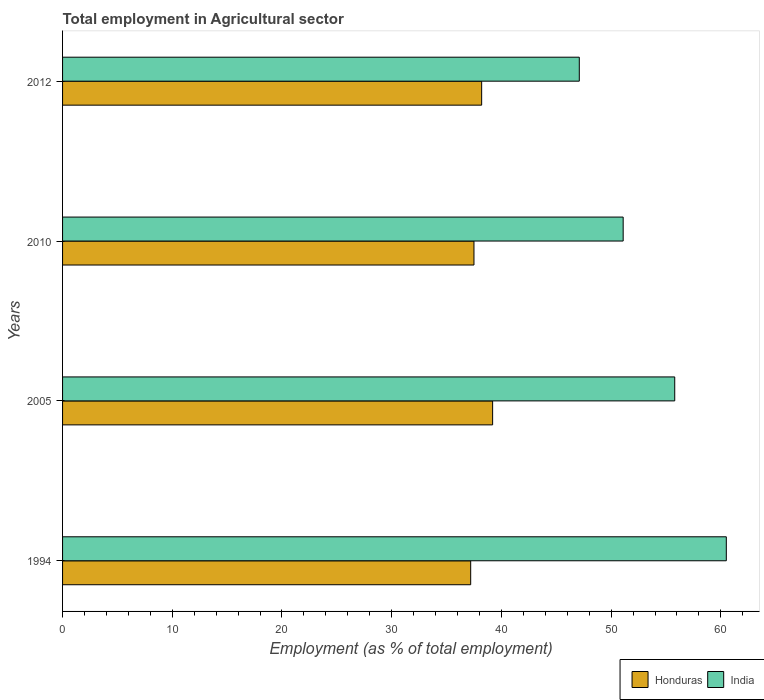How many different coloured bars are there?
Give a very brief answer. 2. How many groups of bars are there?
Provide a succinct answer. 4. Are the number of bars per tick equal to the number of legend labels?
Keep it short and to the point. Yes. What is the employment in agricultural sector in India in 2005?
Provide a succinct answer. 55.8. Across all years, what is the maximum employment in agricultural sector in India?
Provide a short and direct response. 60.5. Across all years, what is the minimum employment in agricultural sector in Honduras?
Your answer should be very brief. 37.2. In which year was the employment in agricultural sector in Honduras minimum?
Your answer should be very brief. 1994. What is the total employment in agricultural sector in India in the graph?
Offer a terse response. 214.5. What is the difference between the employment in agricultural sector in India in 2010 and that in 2012?
Keep it short and to the point. 4. What is the difference between the employment in agricultural sector in India in 2010 and the employment in agricultural sector in Honduras in 2005?
Your answer should be compact. 11.9. What is the average employment in agricultural sector in Honduras per year?
Give a very brief answer. 38.03. In the year 2012, what is the difference between the employment in agricultural sector in India and employment in agricultural sector in Honduras?
Give a very brief answer. 8.9. In how many years, is the employment in agricultural sector in Honduras greater than 6 %?
Your answer should be very brief. 4. What is the ratio of the employment in agricultural sector in Honduras in 2005 to that in 2012?
Give a very brief answer. 1.03. Is the employment in agricultural sector in Honduras in 2005 less than that in 2010?
Provide a short and direct response. No. What is the difference between the highest and the second highest employment in agricultural sector in India?
Keep it short and to the point. 4.7. What is the difference between the highest and the lowest employment in agricultural sector in India?
Make the answer very short. 13.4. In how many years, is the employment in agricultural sector in India greater than the average employment in agricultural sector in India taken over all years?
Keep it short and to the point. 2. What does the 1st bar from the top in 1994 represents?
Give a very brief answer. India. Are all the bars in the graph horizontal?
Offer a terse response. Yes. Are the values on the major ticks of X-axis written in scientific E-notation?
Offer a very short reply. No. Does the graph contain any zero values?
Make the answer very short. No. Does the graph contain grids?
Your answer should be compact. No. Where does the legend appear in the graph?
Your answer should be compact. Bottom right. How many legend labels are there?
Offer a very short reply. 2. How are the legend labels stacked?
Offer a very short reply. Horizontal. What is the title of the graph?
Provide a succinct answer. Total employment in Agricultural sector. What is the label or title of the X-axis?
Ensure brevity in your answer.  Employment (as % of total employment). What is the label or title of the Y-axis?
Offer a very short reply. Years. What is the Employment (as % of total employment) in Honduras in 1994?
Give a very brief answer. 37.2. What is the Employment (as % of total employment) of India in 1994?
Offer a terse response. 60.5. What is the Employment (as % of total employment) in Honduras in 2005?
Your response must be concise. 39.2. What is the Employment (as % of total employment) in India in 2005?
Your response must be concise. 55.8. What is the Employment (as % of total employment) in Honduras in 2010?
Your answer should be very brief. 37.5. What is the Employment (as % of total employment) in India in 2010?
Make the answer very short. 51.1. What is the Employment (as % of total employment) of Honduras in 2012?
Your response must be concise. 38.2. What is the Employment (as % of total employment) of India in 2012?
Make the answer very short. 47.1. Across all years, what is the maximum Employment (as % of total employment) in Honduras?
Provide a short and direct response. 39.2. Across all years, what is the maximum Employment (as % of total employment) in India?
Ensure brevity in your answer.  60.5. Across all years, what is the minimum Employment (as % of total employment) of Honduras?
Give a very brief answer. 37.2. Across all years, what is the minimum Employment (as % of total employment) in India?
Give a very brief answer. 47.1. What is the total Employment (as % of total employment) of Honduras in the graph?
Your response must be concise. 152.1. What is the total Employment (as % of total employment) of India in the graph?
Offer a very short reply. 214.5. What is the difference between the Employment (as % of total employment) of India in 1994 and that in 2005?
Make the answer very short. 4.7. What is the difference between the Employment (as % of total employment) in India in 1994 and that in 2010?
Make the answer very short. 9.4. What is the difference between the Employment (as % of total employment) in Honduras in 1994 and that in 2012?
Give a very brief answer. -1. What is the difference between the Employment (as % of total employment) in India in 1994 and that in 2012?
Make the answer very short. 13.4. What is the difference between the Employment (as % of total employment) of Honduras in 2005 and that in 2010?
Provide a succinct answer. 1.7. What is the difference between the Employment (as % of total employment) of India in 2005 and that in 2010?
Keep it short and to the point. 4.7. What is the difference between the Employment (as % of total employment) in Honduras in 2005 and that in 2012?
Provide a succinct answer. 1. What is the difference between the Employment (as % of total employment) of India in 2005 and that in 2012?
Keep it short and to the point. 8.7. What is the difference between the Employment (as % of total employment) of Honduras in 2010 and that in 2012?
Ensure brevity in your answer.  -0.7. What is the difference between the Employment (as % of total employment) of Honduras in 1994 and the Employment (as % of total employment) of India in 2005?
Your answer should be very brief. -18.6. What is the difference between the Employment (as % of total employment) of Honduras in 2005 and the Employment (as % of total employment) of India in 2010?
Keep it short and to the point. -11.9. What is the difference between the Employment (as % of total employment) of Honduras in 2010 and the Employment (as % of total employment) of India in 2012?
Make the answer very short. -9.6. What is the average Employment (as % of total employment) of Honduras per year?
Provide a short and direct response. 38.02. What is the average Employment (as % of total employment) in India per year?
Your answer should be very brief. 53.62. In the year 1994, what is the difference between the Employment (as % of total employment) in Honduras and Employment (as % of total employment) in India?
Give a very brief answer. -23.3. In the year 2005, what is the difference between the Employment (as % of total employment) of Honduras and Employment (as % of total employment) of India?
Provide a short and direct response. -16.6. What is the ratio of the Employment (as % of total employment) of Honduras in 1994 to that in 2005?
Your answer should be compact. 0.95. What is the ratio of the Employment (as % of total employment) of India in 1994 to that in 2005?
Provide a short and direct response. 1.08. What is the ratio of the Employment (as % of total employment) of Honduras in 1994 to that in 2010?
Make the answer very short. 0.99. What is the ratio of the Employment (as % of total employment) of India in 1994 to that in 2010?
Provide a succinct answer. 1.18. What is the ratio of the Employment (as % of total employment) of Honduras in 1994 to that in 2012?
Make the answer very short. 0.97. What is the ratio of the Employment (as % of total employment) in India in 1994 to that in 2012?
Provide a succinct answer. 1.28. What is the ratio of the Employment (as % of total employment) in Honduras in 2005 to that in 2010?
Provide a succinct answer. 1.05. What is the ratio of the Employment (as % of total employment) of India in 2005 to that in 2010?
Give a very brief answer. 1.09. What is the ratio of the Employment (as % of total employment) in Honduras in 2005 to that in 2012?
Offer a very short reply. 1.03. What is the ratio of the Employment (as % of total employment) in India in 2005 to that in 2012?
Your answer should be compact. 1.18. What is the ratio of the Employment (as % of total employment) of Honduras in 2010 to that in 2012?
Offer a terse response. 0.98. What is the ratio of the Employment (as % of total employment) in India in 2010 to that in 2012?
Offer a very short reply. 1.08. What is the difference between the highest and the second highest Employment (as % of total employment) of Honduras?
Your answer should be very brief. 1. What is the difference between the highest and the second highest Employment (as % of total employment) of India?
Ensure brevity in your answer.  4.7. What is the difference between the highest and the lowest Employment (as % of total employment) of India?
Provide a succinct answer. 13.4. 